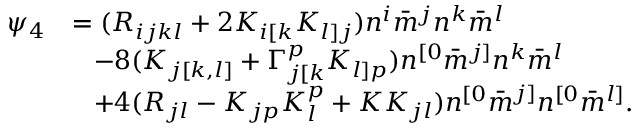<formula> <loc_0><loc_0><loc_500><loc_500>\begin{array} { r l } { \psi _ { 4 } } & { = ( R _ { i j k l } + 2 K _ { i [ k } K _ { l ] j } ) n ^ { i } \bar { m } ^ { j } n ^ { k } \bar { m } ^ { l } } \\ & { \, - 8 ( K _ { j [ k , l ] } + \Gamma _ { j [ k } ^ { p } K _ { l ] p } ) n ^ { [ 0 } \bar { m } ^ { j ] } n ^ { k } \bar { m } ^ { l } } \\ & { \, + 4 ( R _ { j l } - K _ { j p } K _ { l } ^ { p } + K K _ { j l } ) n ^ { [ 0 } \bar { m } ^ { j ] } n ^ { [ 0 } \bar { m } ^ { l ] } . } \end{array}</formula> 